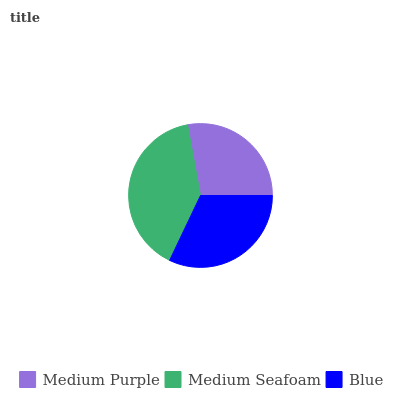Is Medium Purple the minimum?
Answer yes or no. Yes. Is Medium Seafoam the maximum?
Answer yes or no. Yes. Is Blue the minimum?
Answer yes or no. No. Is Blue the maximum?
Answer yes or no. No. Is Medium Seafoam greater than Blue?
Answer yes or no. Yes. Is Blue less than Medium Seafoam?
Answer yes or no. Yes. Is Blue greater than Medium Seafoam?
Answer yes or no. No. Is Medium Seafoam less than Blue?
Answer yes or no. No. Is Blue the high median?
Answer yes or no. Yes. Is Blue the low median?
Answer yes or no. Yes. Is Medium Purple the high median?
Answer yes or no. No. Is Medium Purple the low median?
Answer yes or no. No. 